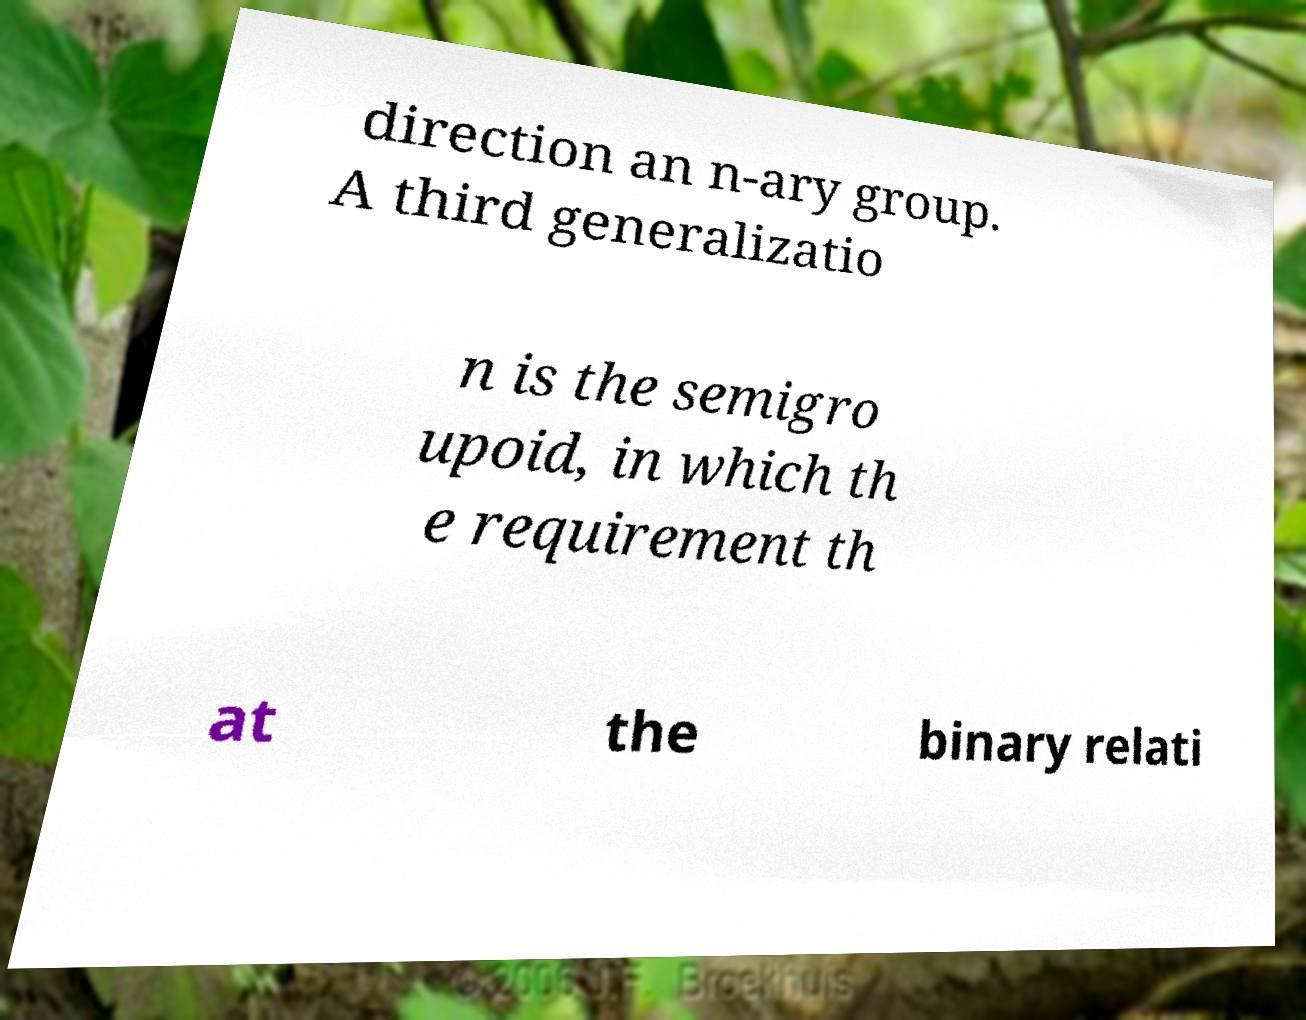Can you accurately transcribe the text from the provided image for me? direction an n-ary group. A third generalizatio n is the semigro upoid, in which th e requirement th at the binary relati 